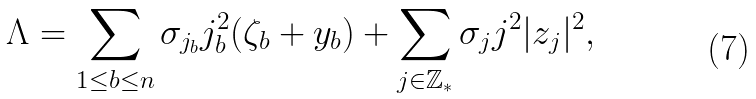Convert formula to latex. <formula><loc_0><loc_0><loc_500><loc_500>\Lambda = \sum _ { 1 \leq b \leq n } \sigma _ { j _ { b } } j _ { b } ^ { 2 } ( \zeta _ { b } + y _ { b } ) + \sum _ { j \in \mathbb { Z } _ { * } } \sigma _ { j } j ^ { 2 } | z _ { j } | ^ { 2 } ,</formula> 